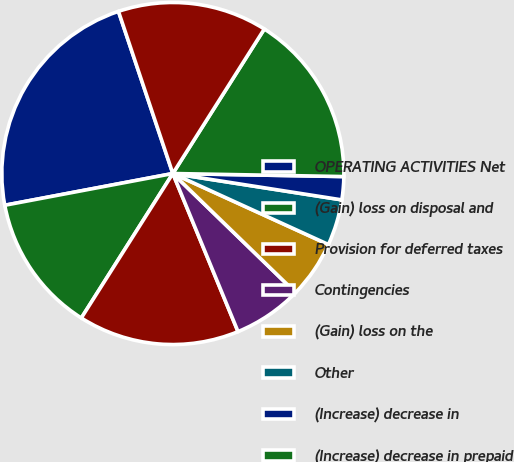Convert chart to OTSL. <chart><loc_0><loc_0><loc_500><loc_500><pie_chart><fcel>OPERATING ACTIVITIES Net<fcel>(Gain) loss on disposal and<fcel>Provision for deferred taxes<fcel>Contingencies<fcel>(Gain) loss on the<fcel>Other<fcel>(Increase) decrease in<fcel>(Increase) decrease in prepaid<fcel>(Increase) decrease in other<nl><fcel>22.82%<fcel>13.04%<fcel>15.21%<fcel>6.52%<fcel>5.44%<fcel>4.35%<fcel>2.18%<fcel>16.3%<fcel>14.13%<nl></chart> 